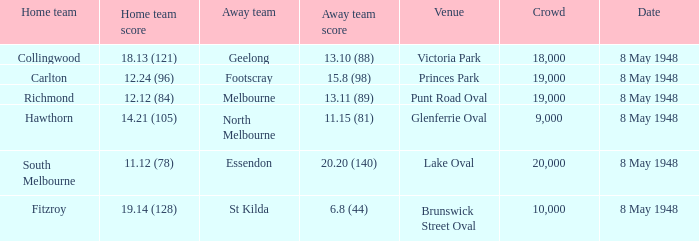Which away team has a home score of 14.21 (105)? North Melbourne. 